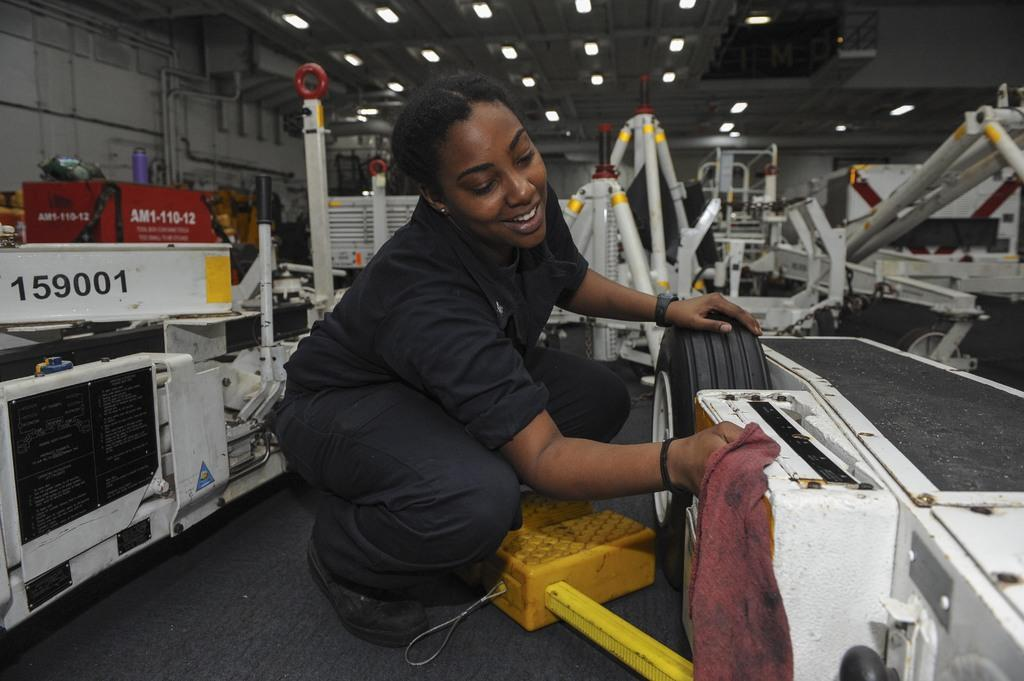Who is the main subject in the image? There is a lady in the center of the image. What is the lady holding in the image? The lady is holding a cloth. What is the lady doing in the image? The lady is cleaning a vehicle. What else can be seen in the background of the image? There are vehicles in the background of the image. What is visible at the top of the image? There are lights visible at the top of the image. Where is the flock of goldfish playing in the image? There is no flock of goldfish present in the image. What type of playground equipment can be seen in the image? There is no playground equipment present in the image. 